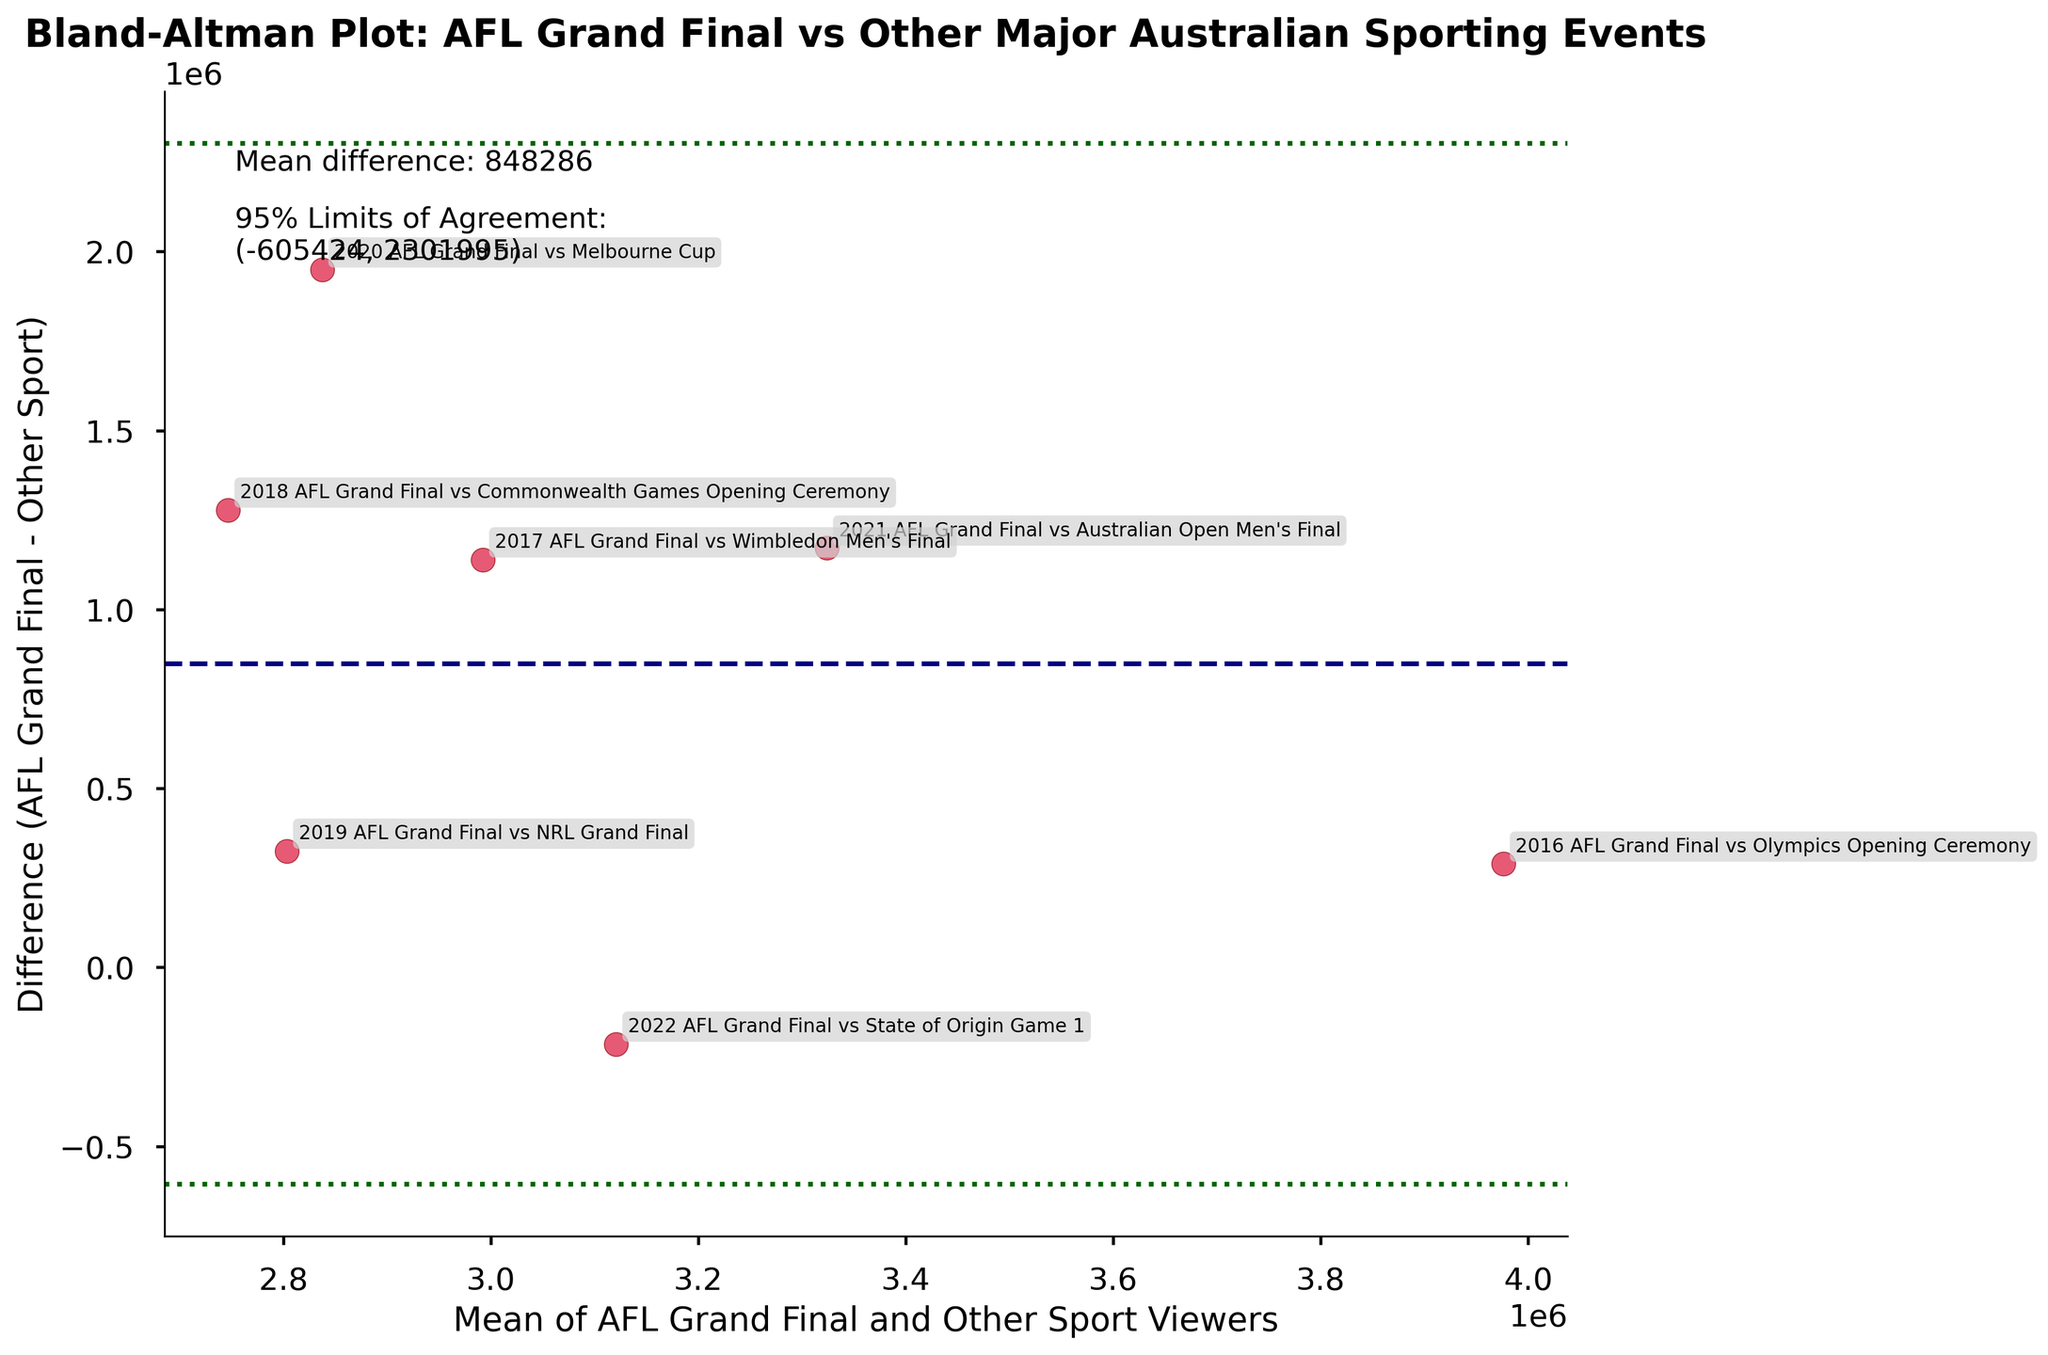What's the title of the plot? The title of the plot is usually located at the top center and summarizes the data being visualized.
Answer: Bland-Altman Plot: AFL Grand Final vs Other Major Australian Sporting Events How many data points are displayed in the plot? This can be determined by counting the number of scatter plot points visible in the plot.
Answer: 7 What's the mean difference between AFL Grand Final and other sports viewers? This information is typically noted in the text within the plot. It's the horizontal line labeled as the mean difference.
Answer: 462857 What are the 95% Limits of Agreement? Limits of agreement are also typically noted within the plot. They are the horizontal lines labeled as the 95% limits of agreement.
Answer: (314132, 611581) Is there any event where the AFL Grand Final had fewer viewers than the other sport? To determine this, look for points below the zero line on the y-axis. These points signify instances where AFL viewership was lower.
Answer: Yes Which event has the maximum mean viewership? To find this, identify the highest value on the x-axis where the average mean is plotted.
Answer: 2021 AFL Grand Final vs Australian Open Men's Final Is there any point where the difference in viewership is zero? This is determined by checking if any data points lie exactly on the horizontal zero line of the y-axis.
Answer: No What can you say about the consistency of viewers for AFL Grand Finals compared to other sports? Consistency can be analyzed by observing the spread of points around the mean difference. If points are close to the mean difference line, it indicates consistency.
Answer: AFL Grand Finals generally have consistently higher or comparable viewership Which event had the closest viewers between AFL Grand Final and the other sport? This can be identified by finding the data point with the smallest difference value, located closest to the zero line on the y-axis.
Answer: 2022 AFL Grand Final vs State of Origin Game 1 